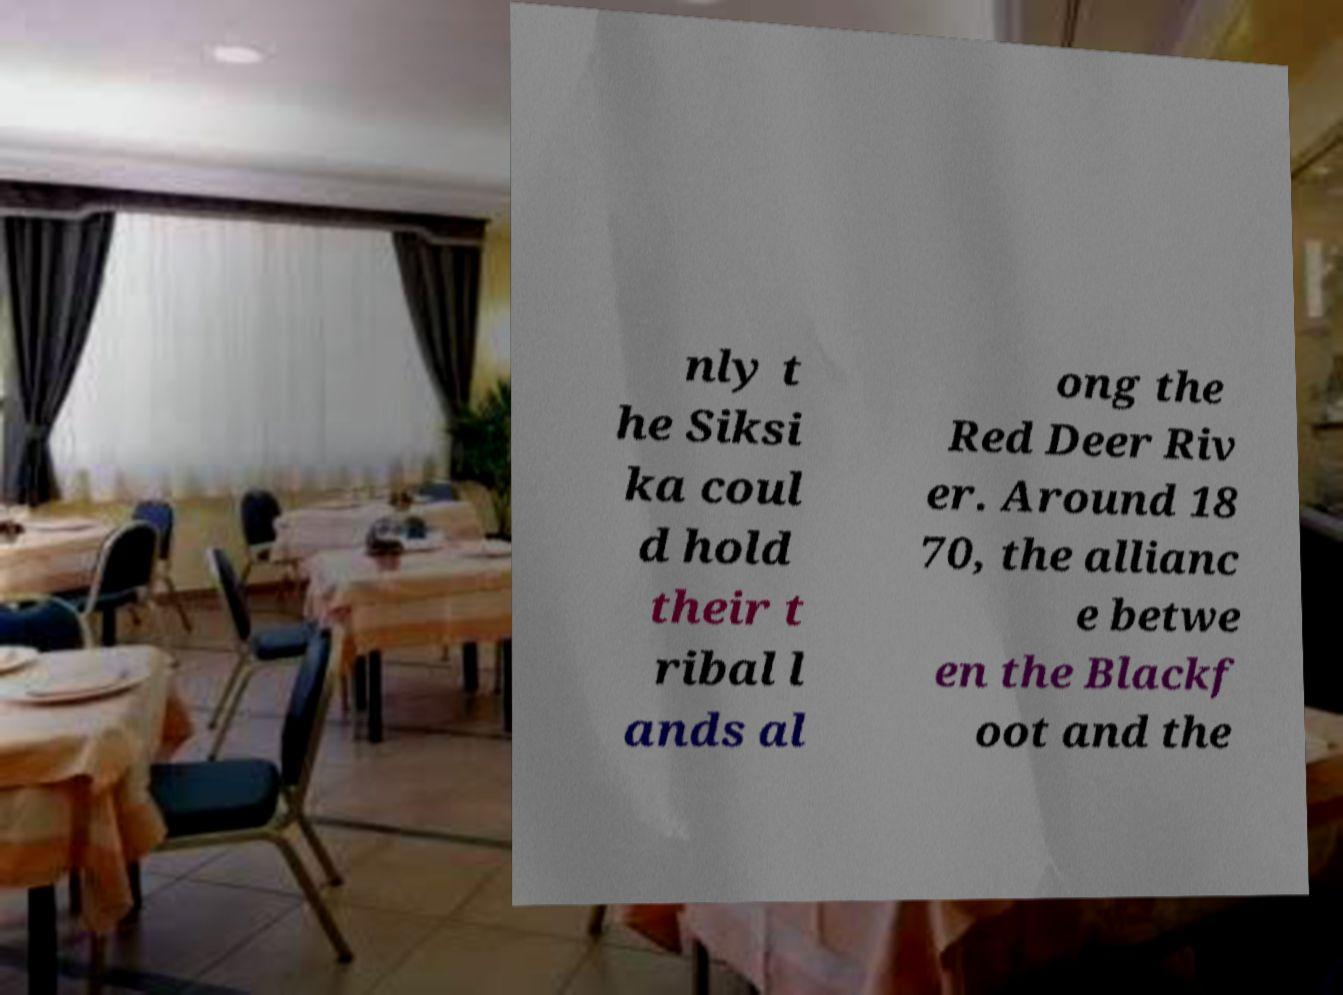Please read and relay the text visible in this image. What does it say? nly t he Siksi ka coul d hold their t ribal l ands al ong the Red Deer Riv er. Around 18 70, the allianc e betwe en the Blackf oot and the 